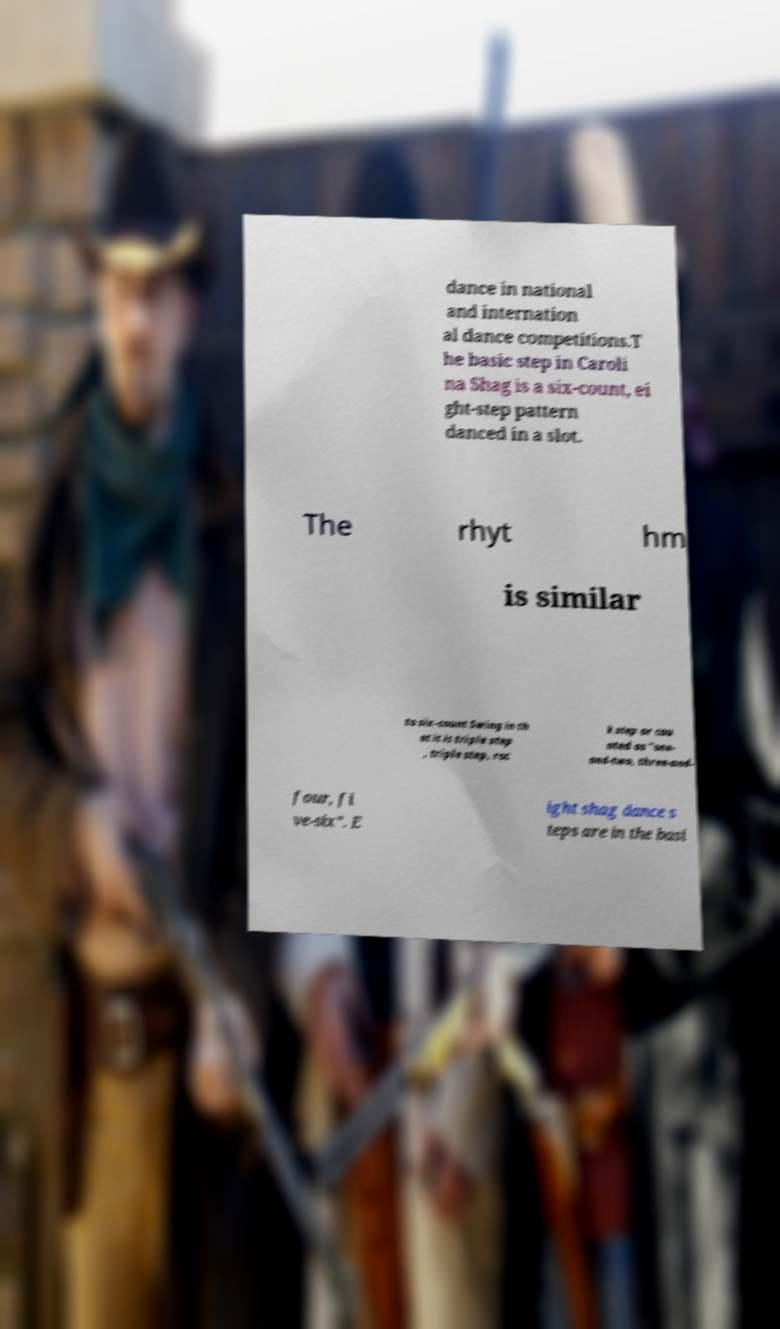I need the written content from this picture converted into text. Can you do that? dance in national and internation al dance competitions.T he basic step in Caroli na Shag is a six-count, ei ght-step pattern danced in a slot. The rhyt hm is similar to six-count Swing in th at it is triple step , triple step, roc k step or cou nted as "one- and-two, three-and- four, fi ve-six". E ight shag dance s teps are in the basi 